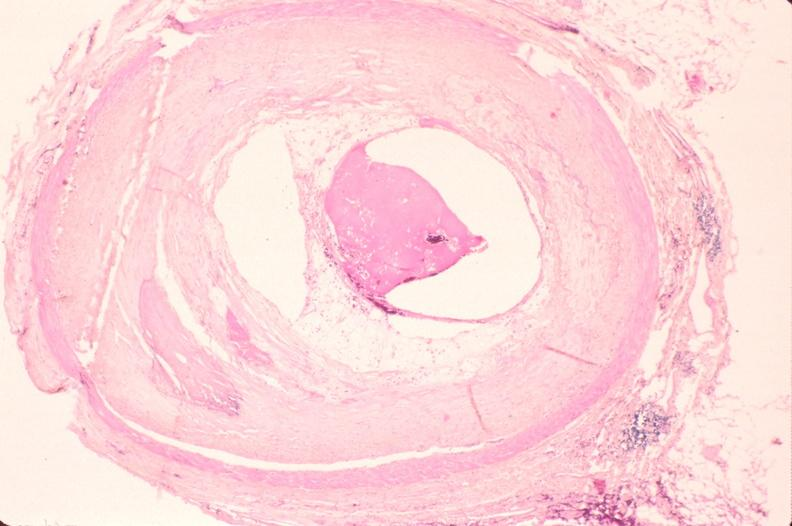where is this in?
Answer the question using a single word or phrase. In vasculature 